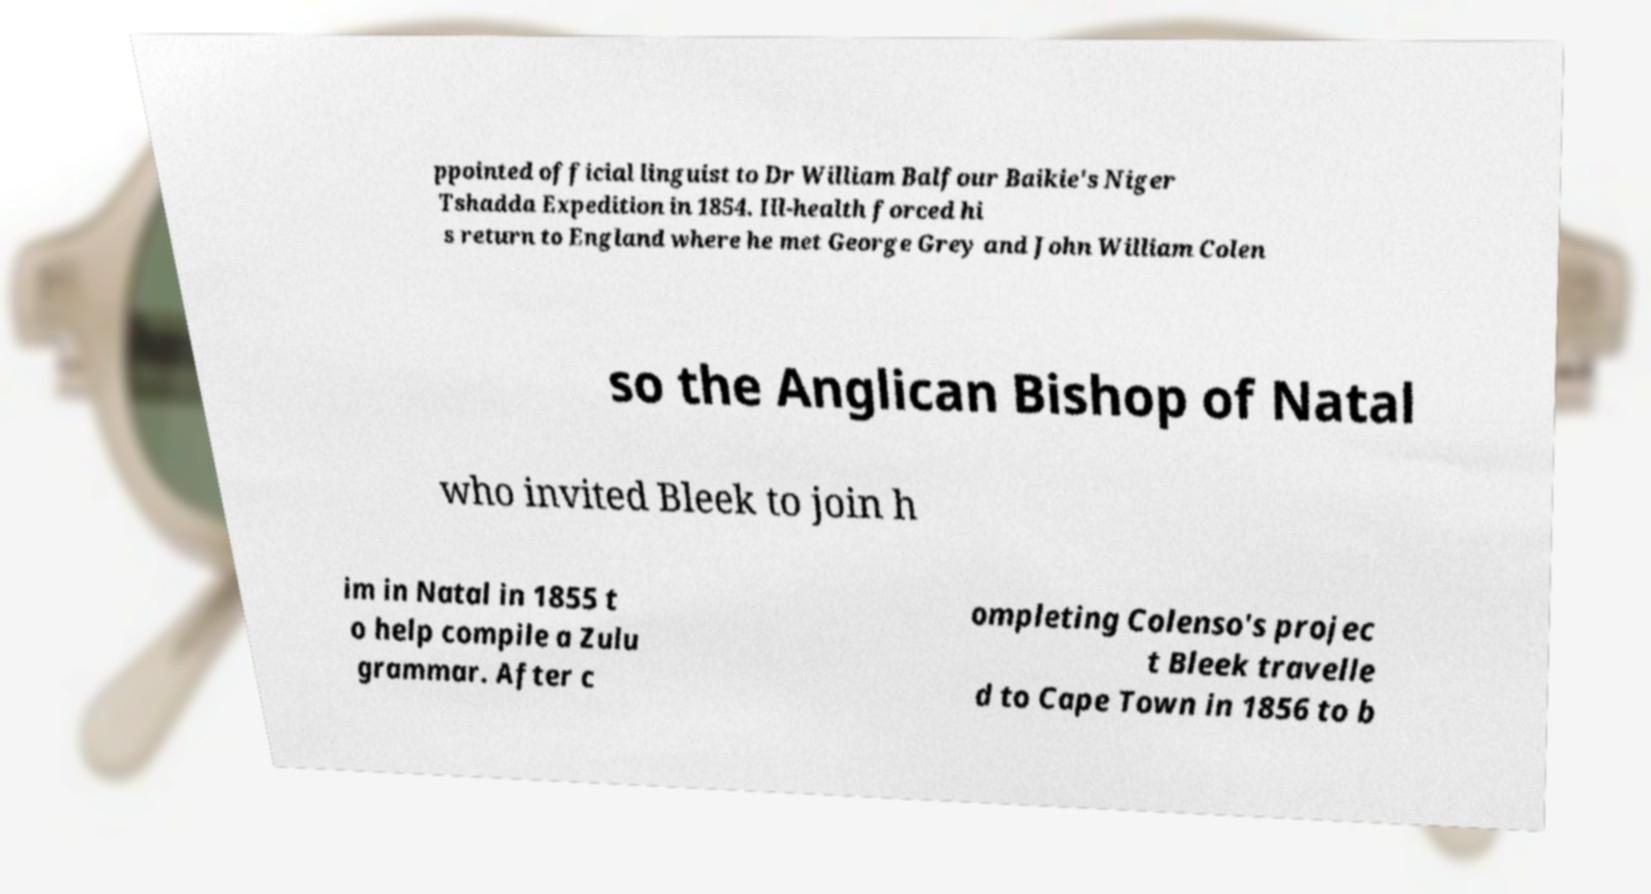Could you extract and type out the text from this image? ppointed official linguist to Dr William Balfour Baikie's Niger Tshadda Expedition in 1854. Ill-health forced hi s return to England where he met George Grey and John William Colen so the Anglican Bishop of Natal who invited Bleek to join h im in Natal in 1855 t o help compile a Zulu grammar. After c ompleting Colenso's projec t Bleek travelle d to Cape Town in 1856 to b 